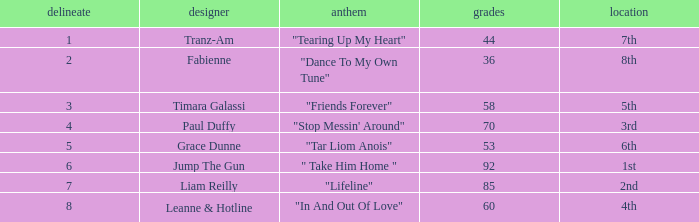What's the highest draw with over 60 points for paul duffy? 4.0. 